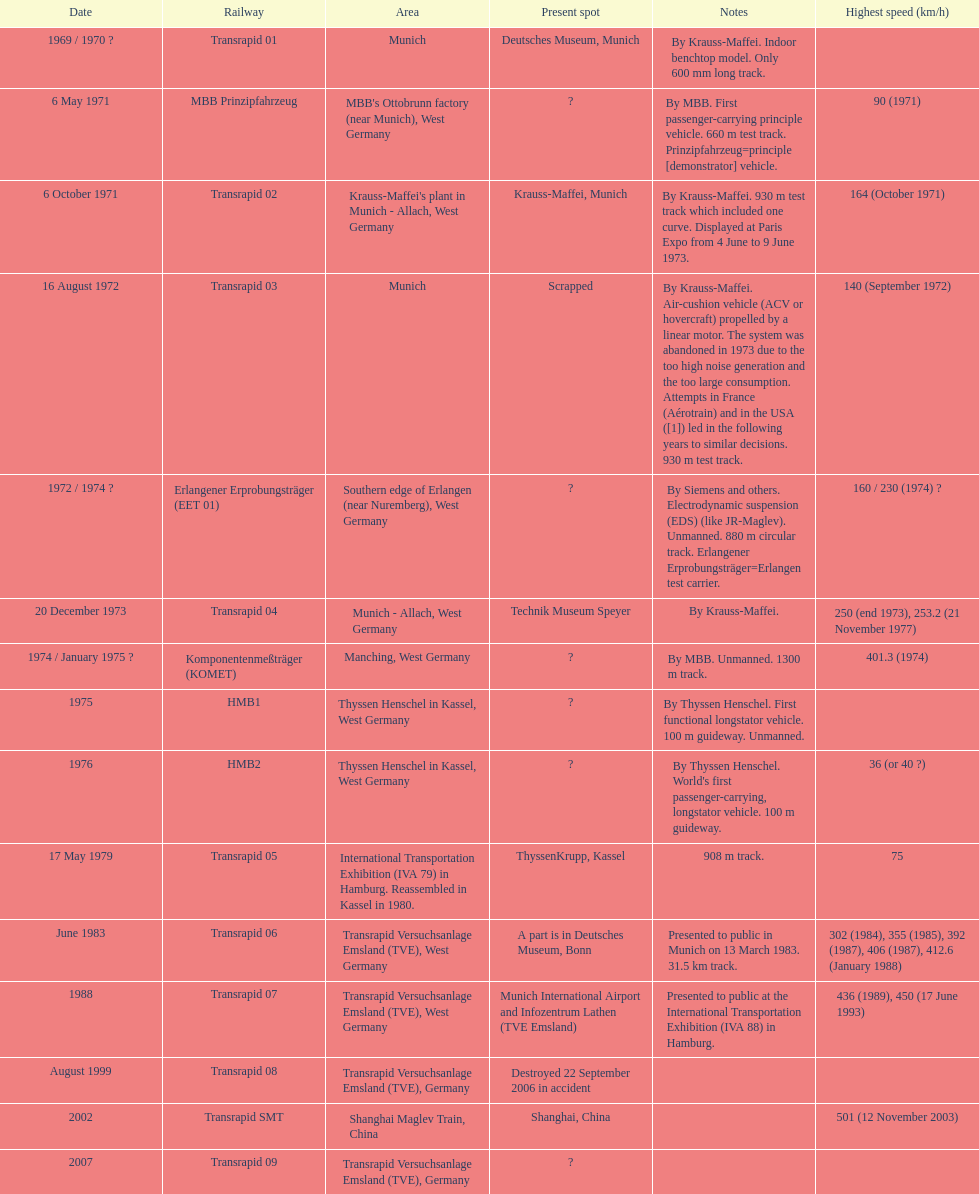What is the number of trains that were either scrapped or destroyed? 2. 